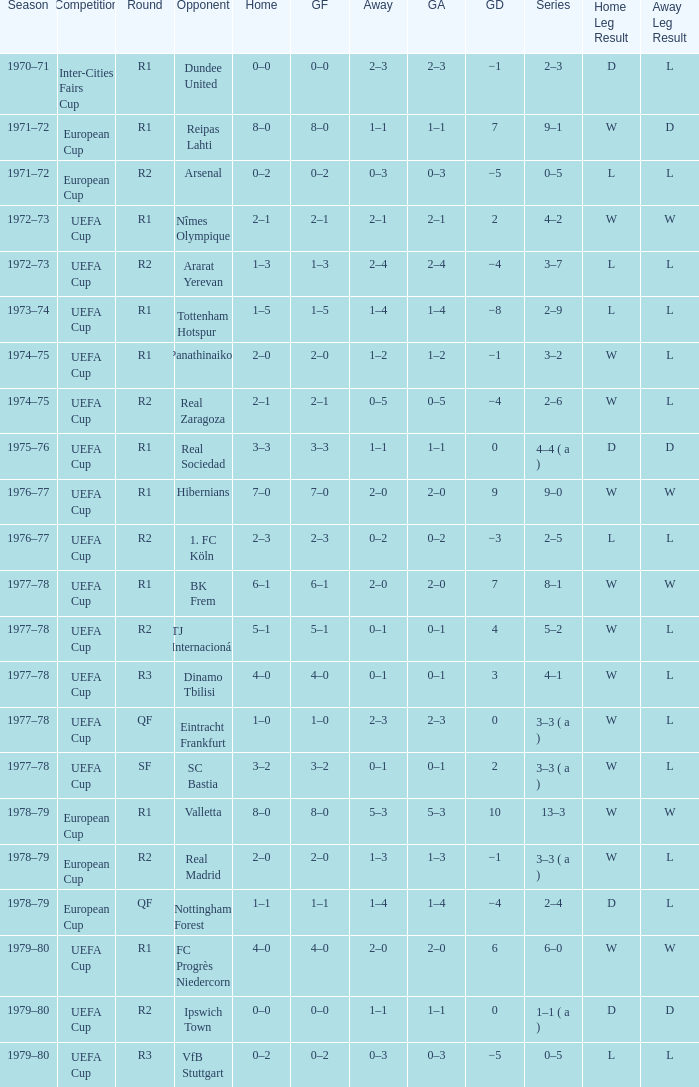Which Season has an Opponent of hibernians? 1976–77. 